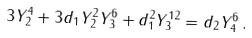<formula> <loc_0><loc_0><loc_500><loc_500>3 Y _ { 2 } ^ { 4 } + 3 d _ { 1 } Y _ { 2 } ^ { 2 } Y _ { 3 } ^ { 6 } + d _ { 1 } ^ { 2 } Y _ { 3 } ^ { 1 2 } = d _ { 2 } Y _ { 4 } ^ { 6 } \, .</formula> 